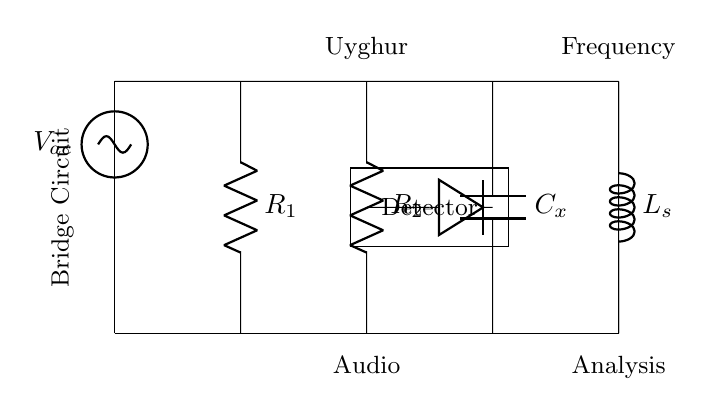What type of circuit is represented? The circuit displayed is a bridge circuit, which consists of multiple components arranged in a way to measure certain electrical properties. This is identified by its specific layout and the presence of resistors, a capacitor, and an inductor, common in bridges used for measurement.
Answer: Bridge circuit What is the applied voltage in the circuit? The applied voltage is indicated as V_ac, representing an alternating current voltage. This is noted at the beginning of the circuit, where the voltage source connects.
Answer: V_ac How many resistors are present in the circuit? There are two resistors present, labeled R_1 and R_2. They are identified by their standard symbol in the circuit diagram, and the labeling confirms their presence.
Answer: 2 What component is used for frequency analysis? The component used for frequency analysis is C_x, which is a capacitor. Capacitors are often used to analyze frequencies because they respond differently to AC signals.
Answer: C_x Which component provides inductance in the circuit? The component that provides inductance is labeled L_s. Inductors are typically represented by the letter L, and their purpose is to oppose changes in current, thus responding to voltage changes in the circuit.
Answer: L_s How is the detector represented in the circuit? The detector is represented by a rectangle shape with the label "Detector" inside. This indicates the functionality of the component in the circuit without being a standard electrical symbol.
Answer: Detector What type of analysis is this bridge circuit used for? The bridge circuit is used for audio frequency analysis, as indicated by the notes placed above and below the circuit. This specifies the application of the circuit in the context of audio signals.
Answer: Audio frequency analysis 